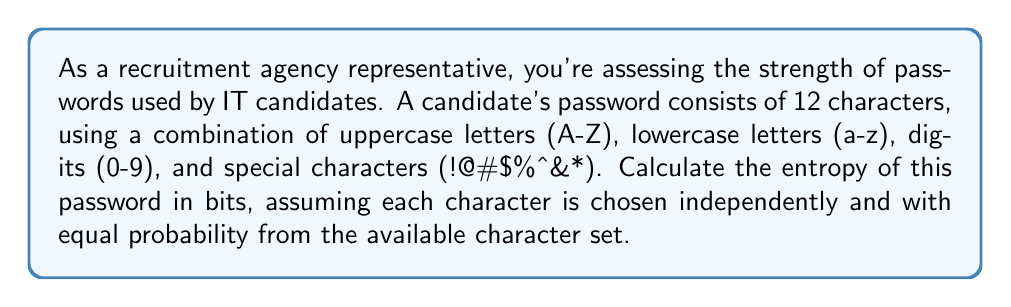What is the answer to this math problem? To calculate the entropy of a password, we use the formula:

$$ H = L \log_2(N) $$

Where:
$H$ = entropy in bits
$L$ = length of the password
$N$ = number of possible characters in the character set

Step 1: Determine the size of the character set (N)
- Uppercase letters: 26
- Lowercase letters: 26
- Digits: 10
- Special characters: 8
Total: $N = 26 + 26 + 10 + 8 = 70$

Step 2: Identify the length of the password (L)
$L = 12$ characters

Step 3: Apply the entropy formula
$$ H = 12 \log_2(70) $$

Step 4: Calculate the result
$$ H = 12 \times 6.129283016944966 $$
$$ H = 73.55139620333959 \text{ bits} $$

Step 5: Round to two decimal places
$$ H \approx 73.55 \text{ bits} $$

This high entropy value indicates a strong password, as it would require a significant amount of computational power to brute-force.
Answer: 73.55 bits 